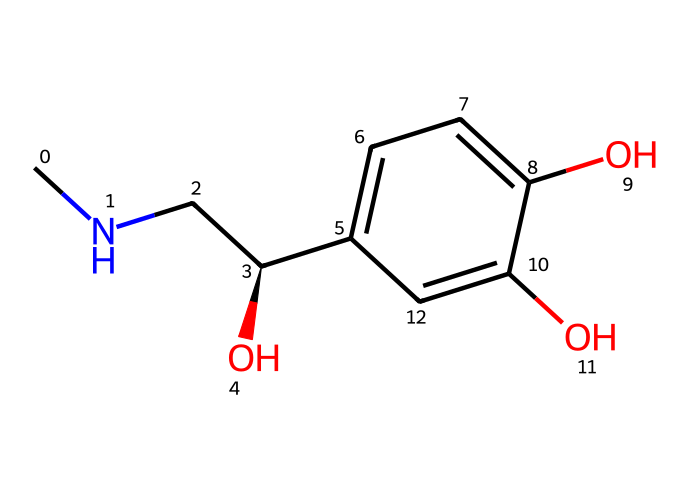What is the primary functional group present in this chemical? The structure features a hydroxyl (-OH) group attached to a carbon, indicating the presence of alcohol functionality.
Answer: hydroxyl group How many hydroxyl groups can be found in this chemical? By analyzing the structure, two -OH groups are clearly visible in the benzene ring, confirming the presence of two hydroxyl groups.
Answer: two What is the molecular formula derived from this chemical structure? The SMILES notations show the presence of carbon, hydrogen, and oxygen atoms, allowing the determination of its molecular formula as C9H13O3.
Answer: C9H13O3 How many rings are present in this chemical structure? The visual examination of the structure reveals a benzene ring, which is characterized by its cyclic form with alternating double bonds.
Answer: one Is this chemical classified as a peptide hormone based on its structure? The presence of amino and hydroxyl groups, along with the absence of peptide bonds, indicates that this is not a peptide hormone but rather a phenolic compound.
Answer: no What role does adrenaline play in the body regarding stress response? The structure aligns with the function of adrenaline as it is recognized as an important hormone in the fight-or-flight response during stressful situations.
Answer: stress response How many stereocenters are present in this chemical structure? By examining the carbon atoms in the structure, one chiral center can be identified, thus indicating the presence of one stereocenter.
Answer: one 